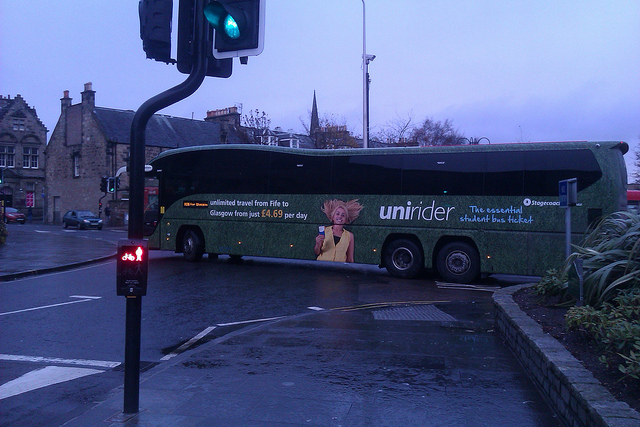What type of vehicle is prominently displayed in the image? The prominent vehicle in the image is a bus. This bus is notably featured and is an integral part of the scene captured. 